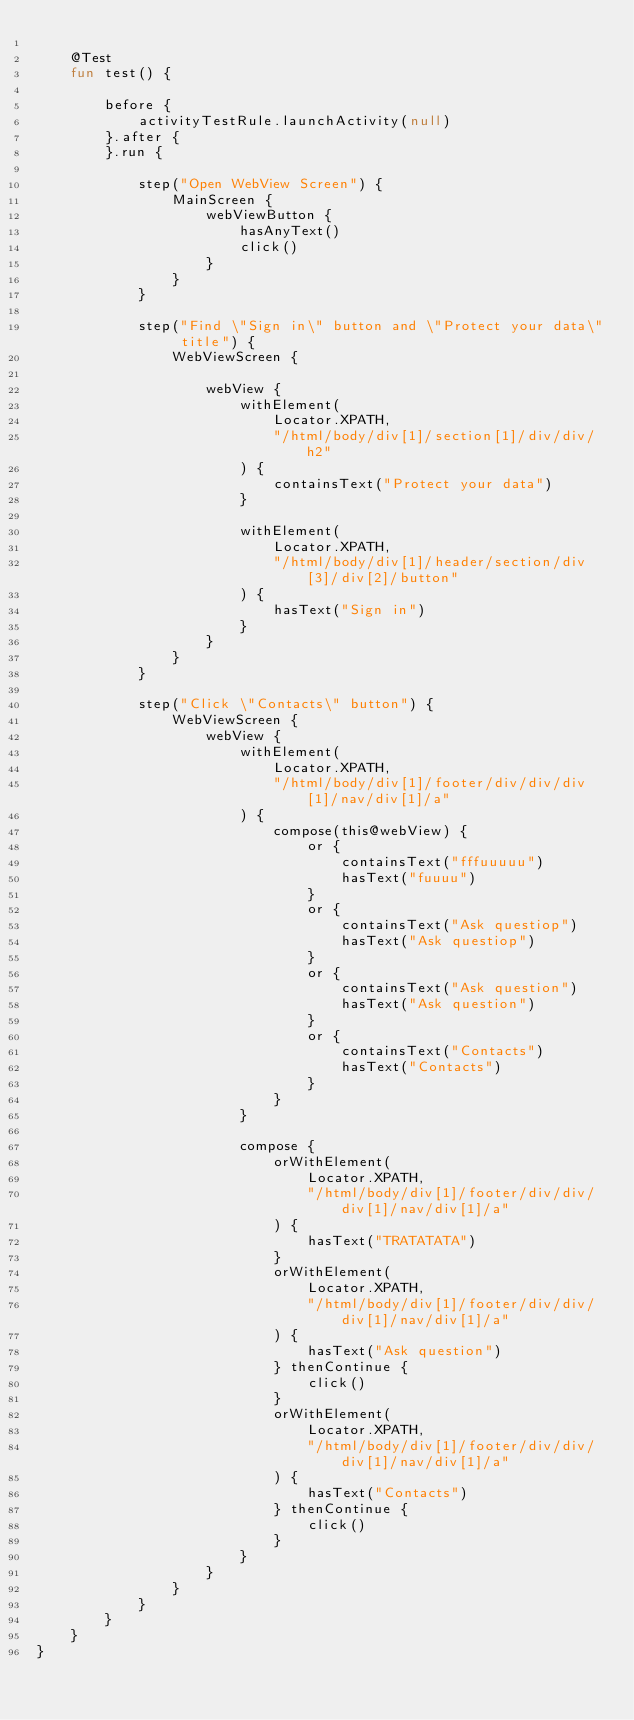Convert code to text. <code><loc_0><loc_0><loc_500><loc_500><_Kotlin_>
    @Test
    fun test() {

        before {
            activityTestRule.launchActivity(null)
        }.after {
        }.run {

            step("Open WebView Screen") {
                MainScreen {
                    webViewButton {
                        hasAnyText()
                        click()
                    }
                }
            }

            step("Find \"Sign in\" button and \"Protect your data\" title") {
                WebViewScreen {

                    webView {
                        withElement(
                            Locator.XPATH,
                            "/html/body/div[1]/section[1]/div/div/h2"
                        ) {
                            containsText("Protect your data")
                        }

                        withElement(
                            Locator.XPATH,
                            "/html/body/div[1]/header/section/div[3]/div[2]/button"
                        ) {
                            hasText("Sign in")
                        }
                    }
                }
            }

            step("Click \"Contacts\" button") {
                WebViewScreen {
                    webView {
                        withElement(
                            Locator.XPATH,
                            "/html/body/div[1]/footer/div/div/div[1]/nav/div[1]/a"
                        ) {
                            compose(this@webView) {
                                or {
                                    containsText("fffuuuuu")
                                    hasText("fuuuu")
                                }
                                or {
                                    containsText("Ask questiop")
                                    hasText("Ask questiop")
                                }
                                or {
                                    containsText("Ask question")
                                    hasText("Ask question")
                                }
                                or {
                                    containsText("Contacts")
                                    hasText("Contacts")
                                }
                            }
                        }

                        compose {
                            orWithElement(
                                Locator.XPATH,
                                "/html/body/div[1]/footer/div/div/div[1]/nav/div[1]/a"
                            ) {
                                hasText("TRATATATA")
                            }
                            orWithElement(
                                Locator.XPATH,
                                "/html/body/div[1]/footer/div/div/div[1]/nav/div[1]/a"
                            ) {
                                hasText("Ask question")
                            } thenContinue {
                                click()
                            }
                            orWithElement(
                                Locator.XPATH,
                                "/html/body/div[1]/footer/div/div/div[1]/nav/div[1]/a"
                            ) {
                                hasText("Contacts")
                            } thenContinue {
                                click()
                            }
                        }
                    }
                }
            }
        }
    }
}</code> 